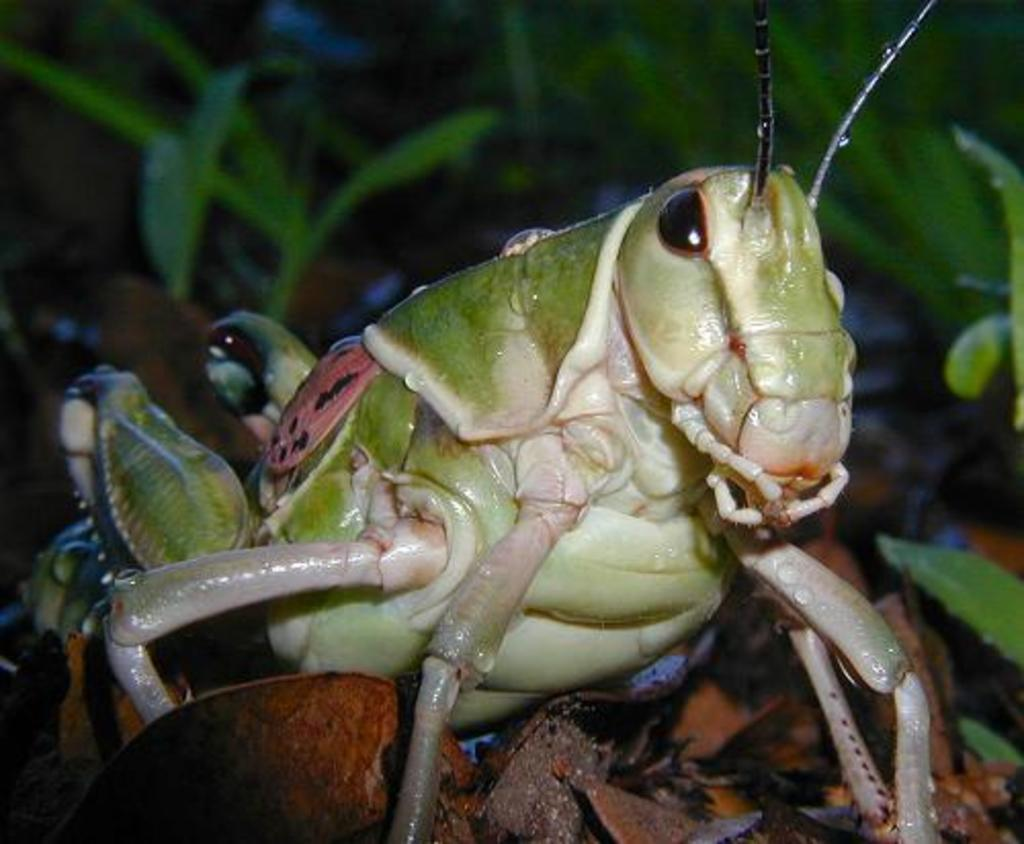What is the main subject of the image? The main subject of the image is grasshoppers, which are located in the center of the image. What can be seen in the background of the image? There are plants visible in the background of the image. What type of current is flowing through the railway in the image? There is no railway or current present in the image; it features grasshoppers and plants. How comfortable are the grasshoppers in the image? The comfort level of the grasshoppers cannot be determined from the image, as it does not provide information about their physical state or emotions. 